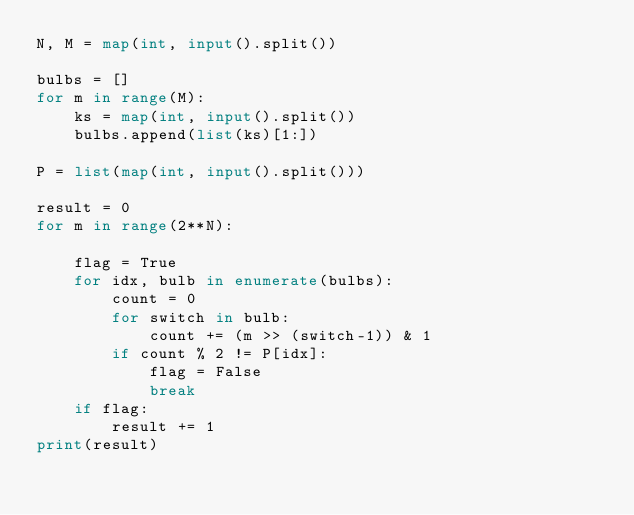Convert code to text. <code><loc_0><loc_0><loc_500><loc_500><_Python_>N, M = map(int, input().split())

bulbs = []
for m in range(M):
    ks = map(int, input().split())
    bulbs.append(list(ks)[1:])

P = list(map(int, input().split()))

result = 0
for m in range(2**N):

    flag = True
    for idx, bulb in enumerate(bulbs):
        count = 0
        for switch in bulb:
            count += (m >> (switch-1)) & 1
        if count % 2 != P[idx]:
            flag = False
            break
    if flag:
        result += 1
print(result)
</code> 